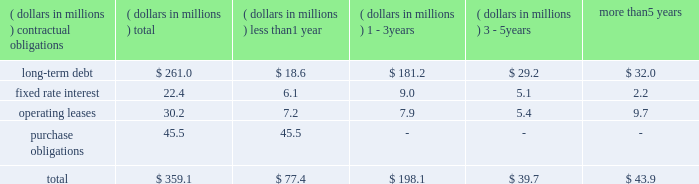In december , our board of directors ratified its authorization of a stock repurchase program in the amount of 1.5 million shares of our common stock .
As of december 31 , 2010 no shares had been repurchased .
We have paid dividends for 71 consecutive years with payments increasing each of the last 19 years .
We paid total dividends of $ .54 per share in 2010 compared with $ .51 per share in 2009 .
Aggregate contractual obligations a summary of our contractual obligations as of december 31 , 2010 , is as follows: .
As of december 31 , 2010 , the liability for uncertain income tax positions was $ 2.7 million .
Due to the high degree of uncertainty regarding timing of potential future cash flows associated with these liabilities , we are unable to make a reasonably reliable estimate of the amount and period in which these liabilities might be paid .
We utilize blanket purchase orders to communicate expected annual requirements to many of our suppliers .
Requirements under blanket purchase orders generally do not become committed until several weeks prior to the company 2019s scheduled unit production .
The purchase obligation amount presented above represents the value of commitments considered firm .
Results of operations our sales from continuing operations in 2010 were $ 1489.3 million surpassing 2009 sales of $ 1375.0 million by 8.3 percent .
The increase in sales was due mostly to significantly higher sales in our water heater operations in china resulting from geographic expansion , market share gains and new product introductions as well as additional sales from our water treatment business acquired in november , 2009 .
Our sales from continuing operations were $ 1451.3 million in 2008 .
The $ 76.3 million decline in sales from 2008 to 2009 was due to lower residential and commercial volume in north america , reflecting softness in the domestic housing market and a slowdown in the commercial water heater business and was partially offset by strong growth in water heater sales in china and improved year over year pricing .
On december 13 , 2010 we entered into a definitive agreement to sell our electrical products company to regal beloit corporation for $ 700 million in cash and approximately 2.83 million shares of regal beloit common stock .
The transaction , which has been approved by both companies' board of directors , is expected to close in the first half of 2011 .
Due to the pending sale , our electrical products segment has been accorded discontinued operations treatment in the accompanying financial statements .
Sales in 2010 , including sales of $ 701.8 million for our electrical products segment , were $ 2191.1 million .
Our gross profit margin for continuing operations in 2010 was 29.9 percent , compared with 28.7 percent in 2009 and 25.8 percent in 2008 .
The improvement in margin from 2009 to 2010 was due to increased volume , cost containment activities and lower warranty costs which more than offset certain inefficiencies resulting from the may flood in our ashland city , tn water heater manufacturing facility .
The increase in profit margin from 2008 to 2009 resulted from increased higher margin china water heater volume , aggressive cost reduction programs and lower material costs .
Selling , general and administrative expense ( sg&a ) was $ 36.9 million higher in 2010 than in 2009 .
The increased sg&a , the majority of which was incurred in our china water heater operation , was associated with selling costs to support higher volume and new product lines .
Additional sg&a associated with our 2009 water treatment acquisition also contributed to the increase .
Sg&a was $ 8.5 million higher in 2009 than 2008 resulting mostly from an $ 8.2 million increase in our china water heater operation in support of higher volumes. .
What percentage of total aggregate contractual obligations is composed of long-term debt? 
Computations: (261.0 / 359.1)
Answer: 0.72682. 